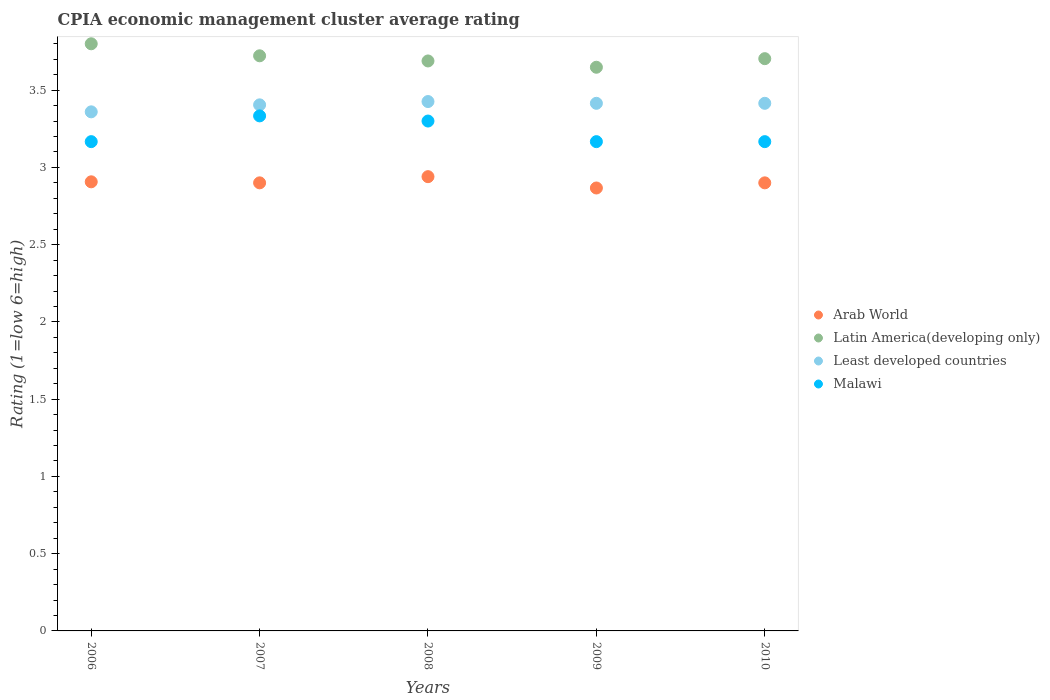What is the CPIA rating in Latin America(developing only) in 2006?
Ensure brevity in your answer.  3.8. Across all years, what is the minimum CPIA rating in Latin America(developing only)?
Offer a terse response. 3.65. In which year was the CPIA rating in Least developed countries minimum?
Ensure brevity in your answer.  2006. What is the total CPIA rating in Arab World in the graph?
Your answer should be very brief. 14.51. What is the difference between the CPIA rating in Arab World in 2007 and that in 2009?
Make the answer very short. 0.03. What is the difference between the CPIA rating in Least developed countries in 2006 and the CPIA rating in Malawi in 2009?
Offer a terse response. 0.19. What is the average CPIA rating in Latin America(developing only) per year?
Make the answer very short. 3.71. In the year 2007, what is the difference between the CPIA rating in Latin America(developing only) and CPIA rating in Least developed countries?
Ensure brevity in your answer.  0.32. What is the ratio of the CPIA rating in Least developed countries in 2006 to that in 2010?
Keep it short and to the point. 0.98. Is the difference between the CPIA rating in Latin America(developing only) in 2007 and 2010 greater than the difference between the CPIA rating in Least developed countries in 2007 and 2010?
Your response must be concise. Yes. What is the difference between the highest and the second highest CPIA rating in Latin America(developing only)?
Ensure brevity in your answer.  0.08. What is the difference between the highest and the lowest CPIA rating in Latin America(developing only)?
Make the answer very short. 0.15. Is the sum of the CPIA rating in Latin America(developing only) in 2008 and 2009 greater than the maximum CPIA rating in Malawi across all years?
Ensure brevity in your answer.  Yes. Does the CPIA rating in Latin America(developing only) monotonically increase over the years?
Provide a succinct answer. No. Is the CPIA rating in Malawi strictly less than the CPIA rating in Least developed countries over the years?
Offer a very short reply. Yes. How many dotlines are there?
Make the answer very short. 4. How many years are there in the graph?
Make the answer very short. 5. What is the difference between two consecutive major ticks on the Y-axis?
Offer a terse response. 0.5. Where does the legend appear in the graph?
Give a very brief answer. Center right. How are the legend labels stacked?
Make the answer very short. Vertical. What is the title of the graph?
Provide a short and direct response. CPIA economic management cluster average rating. What is the label or title of the X-axis?
Give a very brief answer. Years. What is the label or title of the Y-axis?
Make the answer very short. Rating (1=low 6=high). What is the Rating (1=low 6=high) in Arab World in 2006?
Keep it short and to the point. 2.91. What is the Rating (1=low 6=high) of Latin America(developing only) in 2006?
Give a very brief answer. 3.8. What is the Rating (1=low 6=high) in Least developed countries in 2006?
Your answer should be very brief. 3.36. What is the Rating (1=low 6=high) in Malawi in 2006?
Keep it short and to the point. 3.17. What is the Rating (1=low 6=high) of Arab World in 2007?
Keep it short and to the point. 2.9. What is the Rating (1=low 6=high) of Latin America(developing only) in 2007?
Your answer should be compact. 3.72. What is the Rating (1=low 6=high) in Least developed countries in 2007?
Keep it short and to the point. 3.4. What is the Rating (1=low 6=high) of Malawi in 2007?
Keep it short and to the point. 3.33. What is the Rating (1=low 6=high) of Arab World in 2008?
Your response must be concise. 2.94. What is the Rating (1=low 6=high) of Latin America(developing only) in 2008?
Offer a terse response. 3.69. What is the Rating (1=low 6=high) of Least developed countries in 2008?
Your answer should be compact. 3.43. What is the Rating (1=low 6=high) of Arab World in 2009?
Offer a terse response. 2.87. What is the Rating (1=low 6=high) of Latin America(developing only) in 2009?
Offer a very short reply. 3.65. What is the Rating (1=low 6=high) in Least developed countries in 2009?
Make the answer very short. 3.41. What is the Rating (1=low 6=high) in Malawi in 2009?
Your response must be concise. 3.17. What is the Rating (1=low 6=high) in Latin America(developing only) in 2010?
Provide a short and direct response. 3.7. What is the Rating (1=low 6=high) in Least developed countries in 2010?
Ensure brevity in your answer.  3.41. What is the Rating (1=low 6=high) in Malawi in 2010?
Give a very brief answer. 3.17. Across all years, what is the maximum Rating (1=low 6=high) in Arab World?
Your answer should be compact. 2.94. Across all years, what is the maximum Rating (1=low 6=high) in Least developed countries?
Provide a succinct answer. 3.43. Across all years, what is the maximum Rating (1=low 6=high) of Malawi?
Ensure brevity in your answer.  3.33. Across all years, what is the minimum Rating (1=low 6=high) of Arab World?
Make the answer very short. 2.87. Across all years, what is the minimum Rating (1=low 6=high) of Latin America(developing only)?
Make the answer very short. 3.65. Across all years, what is the minimum Rating (1=low 6=high) of Least developed countries?
Offer a terse response. 3.36. Across all years, what is the minimum Rating (1=low 6=high) in Malawi?
Provide a succinct answer. 3.17. What is the total Rating (1=low 6=high) of Arab World in the graph?
Provide a succinct answer. 14.51. What is the total Rating (1=low 6=high) of Latin America(developing only) in the graph?
Provide a succinct answer. 18.56. What is the total Rating (1=low 6=high) of Least developed countries in the graph?
Offer a very short reply. 17.02. What is the total Rating (1=low 6=high) of Malawi in the graph?
Provide a succinct answer. 16.13. What is the difference between the Rating (1=low 6=high) in Arab World in 2006 and that in 2007?
Your answer should be very brief. 0.01. What is the difference between the Rating (1=low 6=high) of Latin America(developing only) in 2006 and that in 2007?
Your answer should be compact. 0.08. What is the difference between the Rating (1=low 6=high) of Least developed countries in 2006 and that in 2007?
Ensure brevity in your answer.  -0.05. What is the difference between the Rating (1=low 6=high) in Arab World in 2006 and that in 2008?
Offer a terse response. -0.03. What is the difference between the Rating (1=low 6=high) of Least developed countries in 2006 and that in 2008?
Ensure brevity in your answer.  -0.07. What is the difference between the Rating (1=low 6=high) in Malawi in 2006 and that in 2008?
Give a very brief answer. -0.13. What is the difference between the Rating (1=low 6=high) of Latin America(developing only) in 2006 and that in 2009?
Your response must be concise. 0.15. What is the difference between the Rating (1=low 6=high) of Least developed countries in 2006 and that in 2009?
Give a very brief answer. -0.06. What is the difference between the Rating (1=low 6=high) of Arab World in 2006 and that in 2010?
Your answer should be compact. 0.01. What is the difference between the Rating (1=low 6=high) in Latin America(developing only) in 2006 and that in 2010?
Give a very brief answer. 0.1. What is the difference between the Rating (1=low 6=high) in Least developed countries in 2006 and that in 2010?
Make the answer very short. -0.06. What is the difference between the Rating (1=low 6=high) of Arab World in 2007 and that in 2008?
Offer a very short reply. -0.04. What is the difference between the Rating (1=low 6=high) of Latin America(developing only) in 2007 and that in 2008?
Your answer should be compact. 0.03. What is the difference between the Rating (1=low 6=high) of Least developed countries in 2007 and that in 2008?
Your response must be concise. -0.02. What is the difference between the Rating (1=low 6=high) of Latin America(developing only) in 2007 and that in 2009?
Offer a terse response. 0.07. What is the difference between the Rating (1=low 6=high) of Least developed countries in 2007 and that in 2009?
Provide a succinct answer. -0.01. What is the difference between the Rating (1=low 6=high) in Malawi in 2007 and that in 2009?
Give a very brief answer. 0.17. What is the difference between the Rating (1=low 6=high) in Latin America(developing only) in 2007 and that in 2010?
Make the answer very short. 0.02. What is the difference between the Rating (1=low 6=high) of Least developed countries in 2007 and that in 2010?
Offer a terse response. -0.01. What is the difference between the Rating (1=low 6=high) of Malawi in 2007 and that in 2010?
Provide a short and direct response. 0.17. What is the difference between the Rating (1=low 6=high) of Arab World in 2008 and that in 2009?
Keep it short and to the point. 0.07. What is the difference between the Rating (1=low 6=high) of Latin America(developing only) in 2008 and that in 2009?
Give a very brief answer. 0.04. What is the difference between the Rating (1=low 6=high) in Least developed countries in 2008 and that in 2009?
Offer a terse response. 0.01. What is the difference between the Rating (1=low 6=high) of Malawi in 2008 and that in 2009?
Your answer should be compact. 0.13. What is the difference between the Rating (1=low 6=high) in Arab World in 2008 and that in 2010?
Keep it short and to the point. 0.04. What is the difference between the Rating (1=low 6=high) of Latin America(developing only) in 2008 and that in 2010?
Make the answer very short. -0.01. What is the difference between the Rating (1=low 6=high) of Least developed countries in 2008 and that in 2010?
Provide a succinct answer. 0.01. What is the difference between the Rating (1=low 6=high) of Malawi in 2008 and that in 2010?
Offer a terse response. 0.13. What is the difference between the Rating (1=low 6=high) of Arab World in 2009 and that in 2010?
Provide a short and direct response. -0.03. What is the difference between the Rating (1=low 6=high) in Latin America(developing only) in 2009 and that in 2010?
Make the answer very short. -0.06. What is the difference between the Rating (1=low 6=high) in Arab World in 2006 and the Rating (1=low 6=high) in Latin America(developing only) in 2007?
Keep it short and to the point. -0.82. What is the difference between the Rating (1=low 6=high) of Arab World in 2006 and the Rating (1=low 6=high) of Least developed countries in 2007?
Your answer should be compact. -0.5. What is the difference between the Rating (1=low 6=high) of Arab World in 2006 and the Rating (1=low 6=high) of Malawi in 2007?
Your response must be concise. -0.43. What is the difference between the Rating (1=low 6=high) in Latin America(developing only) in 2006 and the Rating (1=low 6=high) in Least developed countries in 2007?
Provide a short and direct response. 0.4. What is the difference between the Rating (1=low 6=high) in Latin America(developing only) in 2006 and the Rating (1=low 6=high) in Malawi in 2007?
Give a very brief answer. 0.47. What is the difference between the Rating (1=low 6=high) in Least developed countries in 2006 and the Rating (1=low 6=high) in Malawi in 2007?
Keep it short and to the point. 0.03. What is the difference between the Rating (1=low 6=high) of Arab World in 2006 and the Rating (1=low 6=high) of Latin America(developing only) in 2008?
Your answer should be compact. -0.78. What is the difference between the Rating (1=low 6=high) in Arab World in 2006 and the Rating (1=low 6=high) in Least developed countries in 2008?
Give a very brief answer. -0.52. What is the difference between the Rating (1=low 6=high) in Arab World in 2006 and the Rating (1=low 6=high) in Malawi in 2008?
Make the answer very short. -0.39. What is the difference between the Rating (1=low 6=high) of Latin America(developing only) in 2006 and the Rating (1=low 6=high) of Least developed countries in 2008?
Your answer should be compact. 0.37. What is the difference between the Rating (1=low 6=high) of Latin America(developing only) in 2006 and the Rating (1=low 6=high) of Malawi in 2008?
Your answer should be very brief. 0.5. What is the difference between the Rating (1=low 6=high) of Least developed countries in 2006 and the Rating (1=low 6=high) of Malawi in 2008?
Ensure brevity in your answer.  0.06. What is the difference between the Rating (1=low 6=high) in Arab World in 2006 and the Rating (1=low 6=high) in Latin America(developing only) in 2009?
Keep it short and to the point. -0.74. What is the difference between the Rating (1=low 6=high) of Arab World in 2006 and the Rating (1=low 6=high) of Least developed countries in 2009?
Provide a short and direct response. -0.51. What is the difference between the Rating (1=low 6=high) in Arab World in 2006 and the Rating (1=low 6=high) in Malawi in 2009?
Make the answer very short. -0.26. What is the difference between the Rating (1=low 6=high) of Latin America(developing only) in 2006 and the Rating (1=low 6=high) of Least developed countries in 2009?
Your answer should be compact. 0.39. What is the difference between the Rating (1=low 6=high) in Latin America(developing only) in 2006 and the Rating (1=low 6=high) in Malawi in 2009?
Your response must be concise. 0.63. What is the difference between the Rating (1=low 6=high) in Least developed countries in 2006 and the Rating (1=low 6=high) in Malawi in 2009?
Offer a terse response. 0.19. What is the difference between the Rating (1=low 6=high) of Arab World in 2006 and the Rating (1=low 6=high) of Latin America(developing only) in 2010?
Your answer should be compact. -0.8. What is the difference between the Rating (1=low 6=high) of Arab World in 2006 and the Rating (1=low 6=high) of Least developed countries in 2010?
Make the answer very short. -0.51. What is the difference between the Rating (1=low 6=high) in Arab World in 2006 and the Rating (1=low 6=high) in Malawi in 2010?
Offer a terse response. -0.26. What is the difference between the Rating (1=low 6=high) in Latin America(developing only) in 2006 and the Rating (1=low 6=high) in Least developed countries in 2010?
Offer a very short reply. 0.39. What is the difference between the Rating (1=low 6=high) in Latin America(developing only) in 2006 and the Rating (1=low 6=high) in Malawi in 2010?
Keep it short and to the point. 0.63. What is the difference between the Rating (1=low 6=high) in Least developed countries in 2006 and the Rating (1=low 6=high) in Malawi in 2010?
Give a very brief answer. 0.19. What is the difference between the Rating (1=low 6=high) of Arab World in 2007 and the Rating (1=low 6=high) of Latin America(developing only) in 2008?
Ensure brevity in your answer.  -0.79. What is the difference between the Rating (1=low 6=high) of Arab World in 2007 and the Rating (1=low 6=high) of Least developed countries in 2008?
Provide a short and direct response. -0.53. What is the difference between the Rating (1=low 6=high) in Arab World in 2007 and the Rating (1=low 6=high) in Malawi in 2008?
Make the answer very short. -0.4. What is the difference between the Rating (1=low 6=high) of Latin America(developing only) in 2007 and the Rating (1=low 6=high) of Least developed countries in 2008?
Make the answer very short. 0.3. What is the difference between the Rating (1=low 6=high) of Latin America(developing only) in 2007 and the Rating (1=low 6=high) of Malawi in 2008?
Provide a short and direct response. 0.42. What is the difference between the Rating (1=low 6=high) in Least developed countries in 2007 and the Rating (1=low 6=high) in Malawi in 2008?
Provide a succinct answer. 0.1. What is the difference between the Rating (1=low 6=high) in Arab World in 2007 and the Rating (1=low 6=high) in Latin America(developing only) in 2009?
Offer a terse response. -0.75. What is the difference between the Rating (1=low 6=high) of Arab World in 2007 and the Rating (1=low 6=high) of Least developed countries in 2009?
Offer a terse response. -0.51. What is the difference between the Rating (1=low 6=high) of Arab World in 2007 and the Rating (1=low 6=high) of Malawi in 2009?
Offer a terse response. -0.27. What is the difference between the Rating (1=low 6=high) in Latin America(developing only) in 2007 and the Rating (1=low 6=high) in Least developed countries in 2009?
Provide a succinct answer. 0.31. What is the difference between the Rating (1=low 6=high) of Latin America(developing only) in 2007 and the Rating (1=low 6=high) of Malawi in 2009?
Offer a terse response. 0.56. What is the difference between the Rating (1=low 6=high) of Least developed countries in 2007 and the Rating (1=low 6=high) of Malawi in 2009?
Offer a terse response. 0.24. What is the difference between the Rating (1=low 6=high) in Arab World in 2007 and the Rating (1=low 6=high) in Latin America(developing only) in 2010?
Your response must be concise. -0.8. What is the difference between the Rating (1=low 6=high) of Arab World in 2007 and the Rating (1=low 6=high) of Least developed countries in 2010?
Provide a succinct answer. -0.51. What is the difference between the Rating (1=low 6=high) of Arab World in 2007 and the Rating (1=low 6=high) of Malawi in 2010?
Offer a terse response. -0.27. What is the difference between the Rating (1=low 6=high) of Latin America(developing only) in 2007 and the Rating (1=low 6=high) of Least developed countries in 2010?
Make the answer very short. 0.31. What is the difference between the Rating (1=low 6=high) of Latin America(developing only) in 2007 and the Rating (1=low 6=high) of Malawi in 2010?
Make the answer very short. 0.56. What is the difference between the Rating (1=low 6=high) in Least developed countries in 2007 and the Rating (1=low 6=high) in Malawi in 2010?
Your answer should be compact. 0.24. What is the difference between the Rating (1=low 6=high) in Arab World in 2008 and the Rating (1=low 6=high) in Latin America(developing only) in 2009?
Your answer should be compact. -0.71. What is the difference between the Rating (1=low 6=high) in Arab World in 2008 and the Rating (1=low 6=high) in Least developed countries in 2009?
Give a very brief answer. -0.47. What is the difference between the Rating (1=low 6=high) of Arab World in 2008 and the Rating (1=low 6=high) of Malawi in 2009?
Your answer should be very brief. -0.23. What is the difference between the Rating (1=low 6=high) in Latin America(developing only) in 2008 and the Rating (1=low 6=high) in Least developed countries in 2009?
Provide a short and direct response. 0.27. What is the difference between the Rating (1=low 6=high) of Latin America(developing only) in 2008 and the Rating (1=low 6=high) of Malawi in 2009?
Your answer should be compact. 0.52. What is the difference between the Rating (1=low 6=high) of Least developed countries in 2008 and the Rating (1=low 6=high) of Malawi in 2009?
Provide a succinct answer. 0.26. What is the difference between the Rating (1=low 6=high) of Arab World in 2008 and the Rating (1=low 6=high) of Latin America(developing only) in 2010?
Make the answer very short. -0.76. What is the difference between the Rating (1=low 6=high) of Arab World in 2008 and the Rating (1=low 6=high) of Least developed countries in 2010?
Your response must be concise. -0.47. What is the difference between the Rating (1=low 6=high) of Arab World in 2008 and the Rating (1=low 6=high) of Malawi in 2010?
Ensure brevity in your answer.  -0.23. What is the difference between the Rating (1=low 6=high) in Latin America(developing only) in 2008 and the Rating (1=low 6=high) in Least developed countries in 2010?
Make the answer very short. 0.27. What is the difference between the Rating (1=low 6=high) of Latin America(developing only) in 2008 and the Rating (1=low 6=high) of Malawi in 2010?
Make the answer very short. 0.52. What is the difference between the Rating (1=low 6=high) in Least developed countries in 2008 and the Rating (1=low 6=high) in Malawi in 2010?
Offer a very short reply. 0.26. What is the difference between the Rating (1=low 6=high) in Arab World in 2009 and the Rating (1=low 6=high) in Latin America(developing only) in 2010?
Keep it short and to the point. -0.84. What is the difference between the Rating (1=low 6=high) in Arab World in 2009 and the Rating (1=low 6=high) in Least developed countries in 2010?
Offer a very short reply. -0.55. What is the difference between the Rating (1=low 6=high) in Arab World in 2009 and the Rating (1=low 6=high) in Malawi in 2010?
Keep it short and to the point. -0.3. What is the difference between the Rating (1=low 6=high) in Latin America(developing only) in 2009 and the Rating (1=low 6=high) in Least developed countries in 2010?
Your answer should be very brief. 0.23. What is the difference between the Rating (1=low 6=high) of Latin America(developing only) in 2009 and the Rating (1=low 6=high) of Malawi in 2010?
Ensure brevity in your answer.  0.48. What is the difference between the Rating (1=low 6=high) in Least developed countries in 2009 and the Rating (1=low 6=high) in Malawi in 2010?
Provide a short and direct response. 0.25. What is the average Rating (1=low 6=high) in Arab World per year?
Your answer should be very brief. 2.9. What is the average Rating (1=low 6=high) in Latin America(developing only) per year?
Your answer should be compact. 3.71. What is the average Rating (1=low 6=high) of Least developed countries per year?
Keep it short and to the point. 3.4. What is the average Rating (1=low 6=high) of Malawi per year?
Keep it short and to the point. 3.23. In the year 2006, what is the difference between the Rating (1=low 6=high) in Arab World and Rating (1=low 6=high) in Latin America(developing only)?
Ensure brevity in your answer.  -0.89. In the year 2006, what is the difference between the Rating (1=low 6=high) of Arab World and Rating (1=low 6=high) of Least developed countries?
Your answer should be very brief. -0.45. In the year 2006, what is the difference between the Rating (1=low 6=high) in Arab World and Rating (1=low 6=high) in Malawi?
Your answer should be very brief. -0.26. In the year 2006, what is the difference between the Rating (1=low 6=high) of Latin America(developing only) and Rating (1=low 6=high) of Least developed countries?
Your answer should be very brief. 0.44. In the year 2006, what is the difference between the Rating (1=low 6=high) in Latin America(developing only) and Rating (1=low 6=high) in Malawi?
Your response must be concise. 0.63. In the year 2006, what is the difference between the Rating (1=low 6=high) in Least developed countries and Rating (1=low 6=high) in Malawi?
Ensure brevity in your answer.  0.19. In the year 2007, what is the difference between the Rating (1=low 6=high) in Arab World and Rating (1=low 6=high) in Latin America(developing only)?
Make the answer very short. -0.82. In the year 2007, what is the difference between the Rating (1=low 6=high) in Arab World and Rating (1=low 6=high) in Least developed countries?
Ensure brevity in your answer.  -0.5. In the year 2007, what is the difference between the Rating (1=low 6=high) in Arab World and Rating (1=low 6=high) in Malawi?
Offer a terse response. -0.43. In the year 2007, what is the difference between the Rating (1=low 6=high) of Latin America(developing only) and Rating (1=low 6=high) of Least developed countries?
Your response must be concise. 0.32. In the year 2007, what is the difference between the Rating (1=low 6=high) in Latin America(developing only) and Rating (1=low 6=high) in Malawi?
Provide a succinct answer. 0.39. In the year 2007, what is the difference between the Rating (1=low 6=high) in Least developed countries and Rating (1=low 6=high) in Malawi?
Make the answer very short. 0.07. In the year 2008, what is the difference between the Rating (1=low 6=high) in Arab World and Rating (1=low 6=high) in Latin America(developing only)?
Provide a succinct answer. -0.75. In the year 2008, what is the difference between the Rating (1=low 6=high) in Arab World and Rating (1=low 6=high) in Least developed countries?
Your response must be concise. -0.49. In the year 2008, what is the difference between the Rating (1=low 6=high) of Arab World and Rating (1=low 6=high) of Malawi?
Your response must be concise. -0.36. In the year 2008, what is the difference between the Rating (1=low 6=high) of Latin America(developing only) and Rating (1=low 6=high) of Least developed countries?
Keep it short and to the point. 0.26. In the year 2008, what is the difference between the Rating (1=low 6=high) of Latin America(developing only) and Rating (1=low 6=high) of Malawi?
Keep it short and to the point. 0.39. In the year 2008, what is the difference between the Rating (1=low 6=high) of Least developed countries and Rating (1=low 6=high) of Malawi?
Keep it short and to the point. 0.13. In the year 2009, what is the difference between the Rating (1=low 6=high) of Arab World and Rating (1=low 6=high) of Latin America(developing only)?
Make the answer very short. -0.78. In the year 2009, what is the difference between the Rating (1=low 6=high) in Arab World and Rating (1=low 6=high) in Least developed countries?
Keep it short and to the point. -0.55. In the year 2009, what is the difference between the Rating (1=low 6=high) in Latin America(developing only) and Rating (1=low 6=high) in Least developed countries?
Make the answer very short. 0.23. In the year 2009, what is the difference between the Rating (1=low 6=high) in Latin America(developing only) and Rating (1=low 6=high) in Malawi?
Provide a short and direct response. 0.48. In the year 2009, what is the difference between the Rating (1=low 6=high) in Least developed countries and Rating (1=low 6=high) in Malawi?
Your answer should be very brief. 0.25. In the year 2010, what is the difference between the Rating (1=low 6=high) in Arab World and Rating (1=low 6=high) in Latin America(developing only)?
Offer a terse response. -0.8. In the year 2010, what is the difference between the Rating (1=low 6=high) of Arab World and Rating (1=low 6=high) of Least developed countries?
Keep it short and to the point. -0.51. In the year 2010, what is the difference between the Rating (1=low 6=high) of Arab World and Rating (1=low 6=high) of Malawi?
Give a very brief answer. -0.27. In the year 2010, what is the difference between the Rating (1=low 6=high) of Latin America(developing only) and Rating (1=low 6=high) of Least developed countries?
Keep it short and to the point. 0.29. In the year 2010, what is the difference between the Rating (1=low 6=high) of Latin America(developing only) and Rating (1=low 6=high) of Malawi?
Your response must be concise. 0.54. In the year 2010, what is the difference between the Rating (1=low 6=high) in Least developed countries and Rating (1=low 6=high) in Malawi?
Make the answer very short. 0.25. What is the ratio of the Rating (1=low 6=high) of Arab World in 2006 to that in 2007?
Your answer should be compact. 1. What is the ratio of the Rating (1=low 6=high) of Latin America(developing only) in 2006 to that in 2007?
Your answer should be compact. 1.02. What is the ratio of the Rating (1=low 6=high) in Least developed countries in 2006 to that in 2007?
Your answer should be compact. 0.99. What is the ratio of the Rating (1=low 6=high) in Malawi in 2006 to that in 2007?
Make the answer very short. 0.95. What is the ratio of the Rating (1=low 6=high) of Arab World in 2006 to that in 2008?
Your answer should be very brief. 0.99. What is the ratio of the Rating (1=low 6=high) of Latin America(developing only) in 2006 to that in 2008?
Keep it short and to the point. 1.03. What is the ratio of the Rating (1=low 6=high) in Least developed countries in 2006 to that in 2008?
Your answer should be compact. 0.98. What is the ratio of the Rating (1=low 6=high) in Malawi in 2006 to that in 2008?
Provide a short and direct response. 0.96. What is the ratio of the Rating (1=low 6=high) in Arab World in 2006 to that in 2009?
Your answer should be compact. 1.01. What is the ratio of the Rating (1=low 6=high) of Latin America(developing only) in 2006 to that in 2009?
Your answer should be very brief. 1.04. What is the ratio of the Rating (1=low 6=high) of Least developed countries in 2006 to that in 2009?
Your answer should be very brief. 0.98. What is the ratio of the Rating (1=low 6=high) in Malawi in 2006 to that in 2009?
Give a very brief answer. 1. What is the ratio of the Rating (1=low 6=high) in Least developed countries in 2006 to that in 2010?
Ensure brevity in your answer.  0.98. What is the ratio of the Rating (1=low 6=high) in Malawi in 2006 to that in 2010?
Provide a succinct answer. 1. What is the ratio of the Rating (1=low 6=high) of Arab World in 2007 to that in 2008?
Keep it short and to the point. 0.99. What is the ratio of the Rating (1=low 6=high) in Least developed countries in 2007 to that in 2008?
Ensure brevity in your answer.  0.99. What is the ratio of the Rating (1=low 6=high) in Arab World in 2007 to that in 2009?
Keep it short and to the point. 1.01. What is the ratio of the Rating (1=low 6=high) of Latin America(developing only) in 2007 to that in 2009?
Keep it short and to the point. 1.02. What is the ratio of the Rating (1=low 6=high) of Least developed countries in 2007 to that in 2009?
Give a very brief answer. 1. What is the ratio of the Rating (1=low 6=high) in Malawi in 2007 to that in 2009?
Offer a terse response. 1.05. What is the ratio of the Rating (1=low 6=high) in Arab World in 2007 to that in 2010?
Your response must be concise. 1. What is the ratio of the Rating (1=low 6=high) of Latin America(developing only) in 2007 to that in 2010?
Offer a terse response. 1. What is the ratio of the Rating (1=low 6=high) of Least developed countries in 2007 to that in 2010?
Offer a very short reply. 1. What is the ratio of the Rating (1=low 6=high) of Malawi in 2007 to that in 2010?
Provide a succinct answer. 1.05. What is the ratio of the Rating (1=low 6=high) in Arab World in 2008 to that in 2009?
Ensure brevity in your answer.  1.03. What is the ratio of the Rating (1=low 6=high) of Latin America(developing only) in 2008 to that in 2009?
Give a very brief answer. 1.01. What is the ratio of the Rating (1=low 6=high) in Malawi in 2008 to that in 2009?
Your answer should be very brief. 1.04. What is the ratio of the Rating (1=low 6=high) of Arab World in 2008 to that in 2010?
Your answer should be compact. 1.01. What is the ratio of the Rating (1=low 6=high) of Least developed countries in 2008 to that in 2010?
Make the answer very short. 1. What is the ratio of the Rating (1=low 6=high) in Malawi in 2008 to that in 2010?
Ensure brevity in your answer.  1.04. What is the ratio of the Rating (1=low 6=high) of Latin America(developing only) in 2009 to that in 2010?
Your answer should be very brief. 0.98. What is the difference between the highest and the second highest Rating (1=low 6=high) of Arab World?
Offer a very short reply. 0.03. What is the difference between the highest and the second highest Rating (1=low 6=high) of Latin America(developing only)?
Keep it short and to the point. 0.08. What is the difference between the highest and the second highest Rating (1=low 6=high) of Least developed countries?
Keep it short and to the point. 0.01. What is the difference between the highest and the lowest Rating (1=low 6=high) of Arab World?
Give a very brief answer. 0.07. What is the difference between the highest and the lowest Rating (1=low 6=high) in Latin America(developing only)?
Provide a short and direct response. 0.15. What is the difference between the highest and the lowest Rating (1=low 6=high) of Least developed countries?
Your response must be concise. 0.07. What is the difference between the highest and the lowest Rating (1=low 6=high) of Malawi?
Make the answer very short. 0.17. 